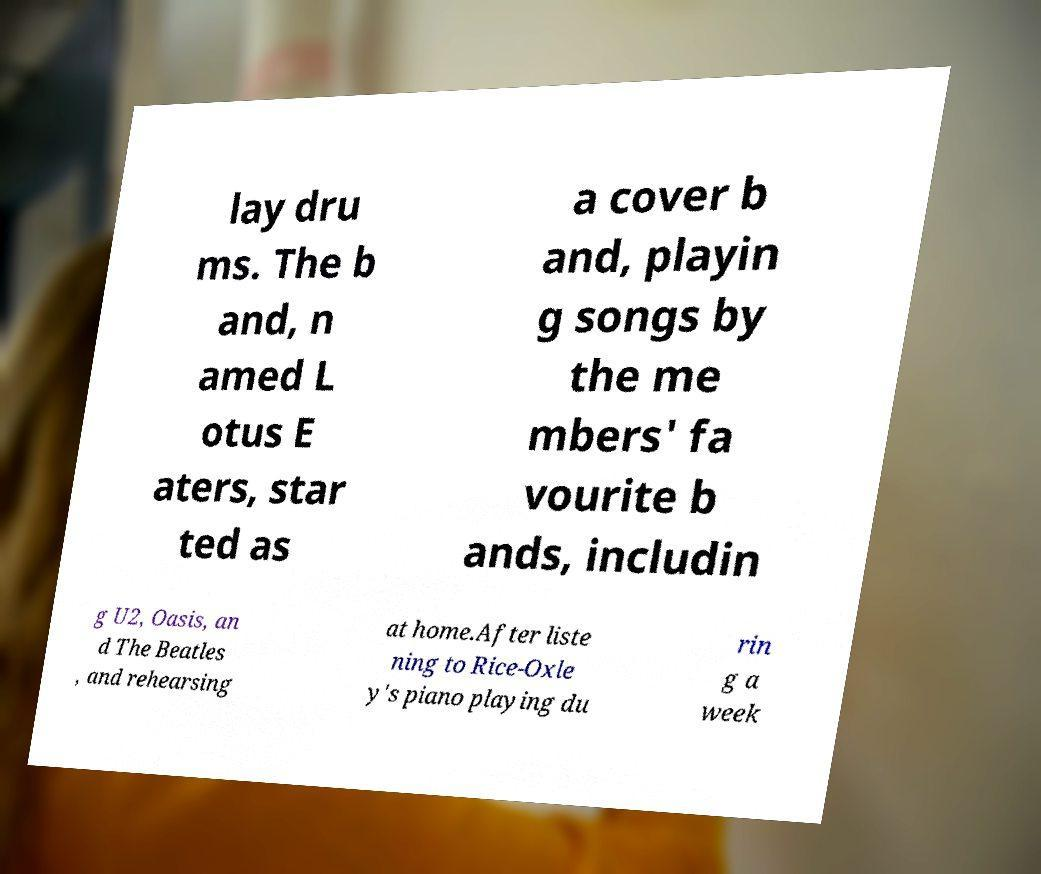What messages or text are displayed in this image? I need them in a readable, typed format. lay dru ms. The b and, n amed L otus E aters, star ted as a cover b and, playin g songs by the me mbers' fa vourite b ands, includin g U2, Oasis, an d The Beatles , and rehearsing at home.After liste ning to Rice-Oxle y's piano playing du rin g a week 